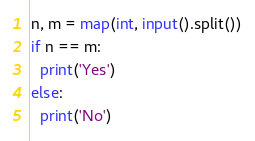Convert code to text. <code><loc_0><loc_0><loc_500><loc_500><_Python_>n, m = map(int, input().split())
if n == m:
  print('Yes')
else:
  print('No')</code> 